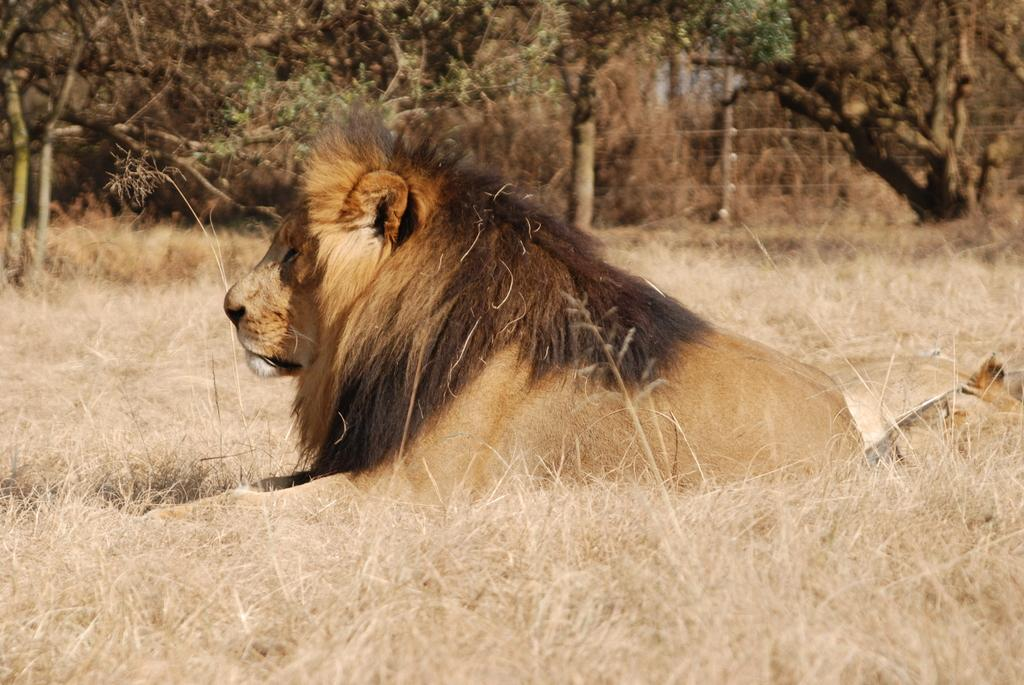What animal is sitting in the image? There is a lion sitting in the image. What type of vegetation is present in the image? There is dried grass in the image. What can be seen in the background of the image? There are trees in the background of the image. What type of pest can be seen crawling on the lion in the image? There are no pests visible on the lion in the image. What material is the brick wall behind the lion made of in the image? There is no brick wall present in the image; it features a lion sitting amidst dried grass and trees in the background. 